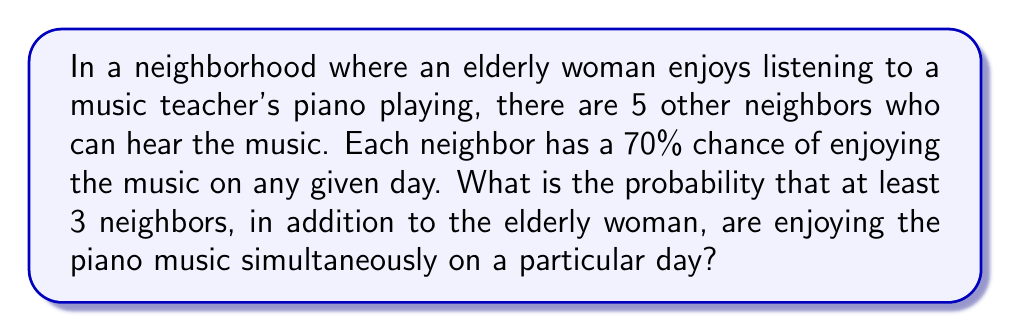Can you solve this math problem? Let's approach this step-by-step:

1) We need to find the probability of 3, 4, or 5 neighbors enjoying the music.

2) Let $p$ be the probability of a neighbor enjoying the music. $p = 0.70$

3) Let $q$ be the probability of a neighbor not enjoying the music. $q = 1 - p = 0.30$

4) We can use the binomial probability formula:

   $P(X = k) = \binom{n}{k} p^k q^{n-k}$

   Where $n = 5$ (total number of other neighbors) and $k$ is the number of neighbors enjoying the music.

5) We need to calculate:

   $P(X \geq 3) = P(X = 3) + P(X = 4) + P(X = 5)$

6) Let's calculate each probability:

   $P(X = 3) = \binom{5}{3} (0.70)^3 (0.30)^2 = 10 \cdot 0.343 \cdot 0.09 = 0.30870$

   $P(X = 4) = \binom{5}{4} (0.70)^4 (0.30)^1 = 5 \cdot 0.2401 \cdot 0.30 = 0.36015$

   $P(X = 5) = \binom{5}{5} (0.70)^5 (0.30)^0 = 1 \cdot 0.16807 \cdot 1 = 0.16807$

7) Sum these probabilities:

   $P(X \geq 3) = 0.30870 + 0.36015 + 0.16807 = 0.83692$

Therefore, the probability is approximately 0.83692 or 83.692%.
Answer: $0.83692$ or $83.692\%$ 